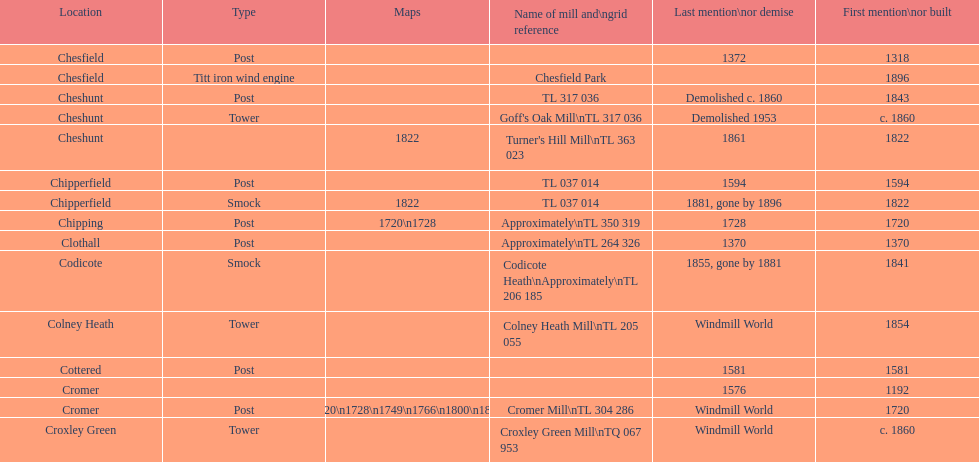Did cromer, chipperfield or cheshunt have the most windmills? Cheshunt. 